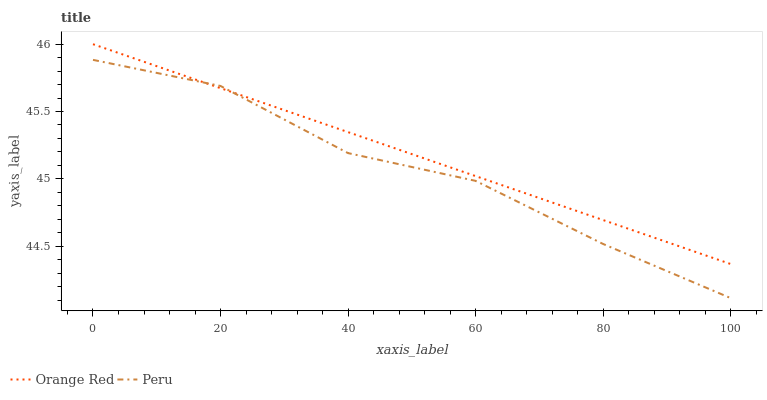Does Peru have the maximum area under the curve?
Answer yes or no. No. Is Peru the smoothest?
Answer yes or no. No. Does Peru have the highest value?
Answer yes or no. No. 